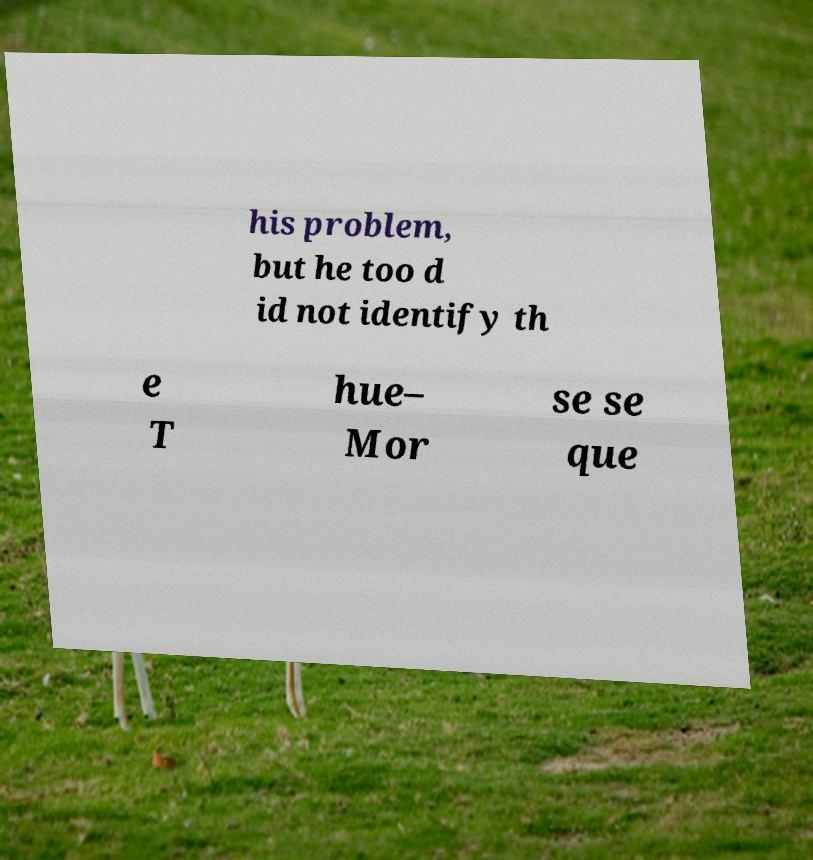Can you read and provide the text displayed in the image?This photo seems to have some interesting text. Can you extract and type it out for me? his problem, but he too d id not identify th e T hue– Mor se se que 